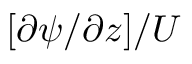<formula> <loc_0><loc_0><loc_500><loc_500>[ { \partial \psi } / { \partial z } ] / U</formula> 